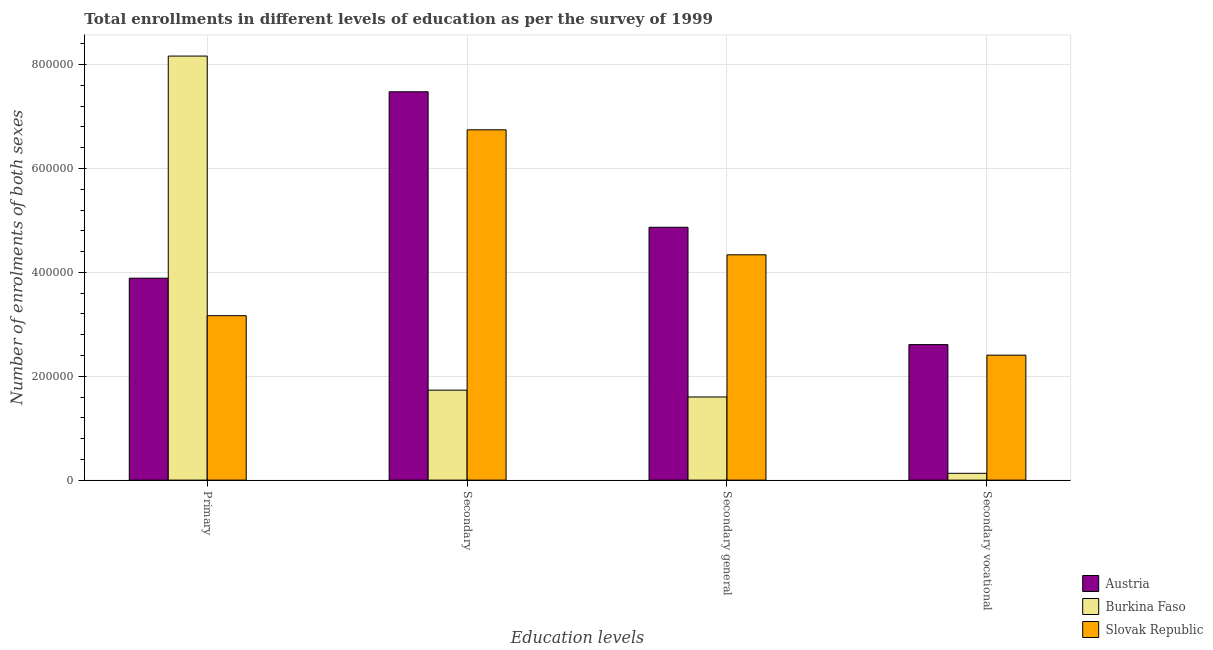How many different coloured bars are there?
Offer a very short reply. 3. How many groups of bars are there?
Ensure brevity in your answer.  4. Are the number of bars per tick equal to the number of legend labels?
Your answer should be very brief. Yes. How many bars are there on the 1st tick from the left?
Your answer should be compact. 3. What is the label of the 3rd group of bars from the left?
Offer a terse response. Secondary general. What is the number of enrolments in primary education in Slovak Republic?
Keep it short and to the point. 3.17e+05. Across all countries, what is the maximum number of enrolments in secondary education?
Your answer should be compact. 7.48e+05. Across all countries, what is the minimum number of enrolments in secondary vocational education?
Keep it short and to the point. 1.31e+04. In which country was the number of enrolments in secondary education maximum?
Your response must be concise. Austria. In which country was the number of enrolments in secondary education minimum?
Make the answer very short. Burkina Faso. What is the total number of enrolments in secondary education in the graph?
Offer a terse response. 1.60e+06. What is the difference between the number of enrolments in primary education in Burkina Faso and that in Austria?
Your answer should be very brief. 4.28e+05. What is the difference between the number of enrolments in primary education in Slovak Republic and the number of enrolments in secondary vocational education in Austria?
Ensure brevity in your answer.  5.57e+04. What is the average number of enrolments in secondary education per country?
Offer a terse response. 5.32e+05. What is the difference between the number of enrolments in secondary vocational education and number of enrolments in primary education in Burkina Faso?
Keep it short and to the point. -8.03e+05. In how many countries, is the number of enrolments in secondary education greater than 680000 ?
Provide a short and direct response. 1. What is the ratio of the number of enrolments in primary education in Burkina Faso to that in Austria?
Ensure brevity in your answer.  2.1. Is the difference between the number of enrolments in secondary vocational education in Austria and Slovak Republic greater than the difference between the number of enrolments in secondary education in Austria and Slovak Republic?
Offer a very short reply. No. What is the difference between the highest and the second highest number of enrolments in secondary general education?
Offer a very short reply. 5.30e+04. What is the difference between the highest and the lowest number of enrolments in secondary general education?
Make the answer very short. 3.27e+05. In how many countries, is the number of enrolments in secondary general education greater than the average number of enrolments in secondary general education taken over all countries?
Provide a succinct answer. 2. Is the sum of the number of enrolments in secondary general education in Austria and Slovak Republic greater than the maximum number of enrolments in secondary education across all countries?
Provide a short and direct response. Yes. Is it the case that in every country, the sum of the number of enrolments in secondary vocational education and number of enrolments in secondary general education is greater than the sum of number of enrolments in primary education and number of enrolments in secondary education?
Give a very brief answer. No. What does the 1st bar from the right in Secondary vocational represents?
Make the answer very short. Slovak Republic. Is it the case that in every country, the sum of the number of enrolments in primary education and number of enrolments in secondary education is greater than the number of enrolments in secondary general education?
Keep it short and to the point. Yes. How many bars are there?
Offer a very short reply. 12. How many countries are there in the graph?
Your answer should be very brief. 3. Does the graph contain grids?
Ensure brevity in your answer.  Yes. How are the legend labels stacked?
Keep it short and to the point. Vertical. What is the title of the graph?
Offer a terse response. Total enrollments in different levels of education as per the survey of 1999. Does "Cote d'Ivoire" appear as one of the legend labels in the graph?
Make the answer very short. No. What is the label or title of the X-axis?
Make the answer very short. Education levels. What is the label or title of the Y-axis?
Your answer should be very brief. Number of enrolments of both sexes. What is the Number of enrolments of both sexes in Austria in Primary?
Provide a succinct answer. 3.89e+05. What is the Number of enrolments of both sexes of Burkina Faso in Primary?
Offer a very short reply. 8.16e+05. What is the Number of enrolments of both sexes of Slovak Republic in Primary?
Provide a succinct answer. 3.17e+05. What is the Number of enrolments of both sexes of Austria in Secondary?
Keep it short and to the point. 7.48e+05. What is the Number of enrolments of both sexes of Burkina Faso in Secondary?
Your response must be concise. 1.73e+05. What is the Number of enrolments of both sexes of Slovak Republic in Secondary?
Keep it short and to the point. 6.74e+05. What is the Number of enrolments of both sexes of Austria in Secondary general?
Give a very brief answer. 4.87e+05. What is the Number of enrolments of both sexes in Burkina Faso in Secondary general?
Offer a very short reply. 1.60e+05. What is the Number of enrolments of both sexes of Slovak Republic in Secondary general?
Provide a short and direct response. 4.34e+05. What is the Number of enrolments of both sexes in Austria in Secondary vocational?
Your response must be concise. 2.61e+05. What is the Number of enrolments of both sexes in Burkina Faso in Secondary vocational?
Your answer should be very brief. 1.31e+04. What is the Number of enrolments of both sexes in Slovak Republic in Secondary vocational?
Offer a terse response. 2.41e+05. Across all Education levels, what is the maximum Number of enrolments of both sexes of Austria?
Ensure brevity in your answer.  7.48e+05. Across all Education levels, what is the maximum Number of enrolments of both sexes of Burkina Faso?
Ensure brevity in your answer.  8.16e+05. Across all Education levels, what is the maximum Number of enrolments of both sexes of Slovak Republic?
Make the answer very short. 6.74e+05. Across all Education levels, what is the minimum Number of enrolments of both sexes in Austria?
Your answer should be compact. 2.61e+05. Across all Education levels, what is the minimum Number of enrolments of both sexes of Burkina Faso?
Provide a short and direct response. 1.31e+04. Across all Education levels, what is the minimum Number of enrolments of both sexes of Slovak Republic?
Your answer should be compact. 2.41e+05. What is the total Number of enrolments of both sexes in Austria in the graph?
Make the answer very short. 1.88e+06. What is the total Number of enrolments of both sexes of Burkina Faso in the graph?
Your answer should be compact. 1.16e+06. What is the total Number of enrolments of both sexes in Slovak Republic in the graph?
Offer a very short reply. 1.67e+06. What is the difference between the Number of enrolments of both sexes in Austria in Primary and that in Secondary?
Provide a succinct answer. -3.59e+05. What is the difference between the Number of enrolments of both sexes of Burkina Faso in Primary and that in Secondary?
Offer a very short reply. 6.43e+05. What is the difference between the Number of enrolments of both sexes in Slovak Republic in Primary and that in Secondary?
Your answer should be very brief. -3.58e+05. What is the difference between the Number of enrolments of both sexes in Austria in Primary and that in Secondary general?
Make the answer very short. -9.80e+04. What is the difference between the Number of enrolments of both sexes in Burkina Faso in Primary and that in Secondary general?
Your answer should be very brief. 6.56e+05. What is the difference between the Number of enrolments of both sexes of Slovak Republic in Primary and that in Secondary general?
Provide a short and direct response. -1.17e+05. What is the difference between the Number of enrolments of both sexes of Austria in Primary and that in Secondary vocational?
Ensure brevity in your answer.  1.28e+05. What is the difference between the Number of enrolments of both sexes in Burkina Faso in Primary and that in Secondary vocational?
Your response must be concise. 8.03e+05. What is the difference between the Number of enrolments of both sexes in Slovak Republic in Primary and that in Secondary vocational?
Ensure brevity in your answer.  7.60e+04. What is the difference between the Number of enrolments of both sexes in Austria in Secondary and that in Secondary general?
Provide a short and direct response. 2.61e+05. What is the difference between the Number of enrolments of both sexes of Burkina Faso in Secondary and that in Secondary general?
Keep it short and to the point. 1.31e+04. What is the difference between the Number of enrolments of both sexes in Slovak Republic in Secondary and that in Secondary general?
Ensure brevity in your answer.  2.41e+05. What is the difference between the Number of enrolments of both sexes in Austria in Secondary and that in Secondary vocational?
Your response must be concise. 4.87e+05. What is the difference between the Number of enrolments of both sexes in Burkina Faso in Secondary and that in Secondary vocational?
Provide a short and direct response. 1.60e+05. What is the difference between the Number of enrolments of both sexes in Slovak Republic in Secondary and that in Secondary vocational?
Make the answer very short. 4.34e+05. What is the difference between the Number of enrolments of both sexes of Austria in Secondary general and that in Secondary vocational?
Your answer should be very brief. 2.26e+05. What is the difference between the Number of enrolments of both sexes of Burkina Faso in Secondary general and that in Secondary vocational?
Your response must be concise. 1.47e+05. What is the difference between the Number of enrolments of both sexes of Slovak Republic in Secondary general and that in Secondary vocational?
Provide a short and direct response. 1.93e+05. What is the difference between the Number of enrolments of both sexes of Austria in Primary and the Number of enrolments of both sexes of Burkina Faso in Secondary?
Keep it short and to the point. 2.16e+05. What is the difference between the Number of enrolments of both sexes in Austria in Primary and the Number of enrolments of both sexes in Slovak Republic in Secondary?
Give a very brief answer. -2.86e+05. What is the difference between the Number of enrolments of both sexes of Burkina Faso in Primary and the Number of enrolments of both sexes of Slovak Republic in Secondary?
Ensure brevity in your answer.  1.42e+05. What is the difference between the Number of enrolments of both sexes of Austria in Primary and the Number of enrolments of both sexes of Burkina Faso in Secondary general?
Your answer should be very brief. 2.29e+05. What is the difference between the Number of enrolments of both sexes of Austria in Primary and the Number of enrolments of both sexes of Slovak Republic in Secondary general?
Give a very brief answer. -4.50e+04. What is the difference between the Number of enrolments of both sexes in Burkina Faso in Primary and the Number of enrolments of both sexes in Slovak Republic in Secondary general?
Offer a very short reply. 3.83e+05. What is the difference between the Number of enrolments of both sexes in Austria in Primary and the Number of enrolments of both sexes in Burkina Faso in Secondary vocational?
Ensure brevity in your answer.  3.76e+05. What is the difference between the Number of enrolments of both sexes in Austria in Primary and the Number of enrolments of both sexes in Slovak Republic in Secondary vocational?
Your answer should be compact. 1.48e+05. What is the difference between the Number of enrolments of both sexes of Burkina Faso in Primary and the Number of enrolments of both sexes of Slovak Republic in Secondary vocational?
Your response must be concise. 5.76e+05. What is the difference between the Number of enrolments of both sexes in Austria in Secondary and the Number of enrolments of both sexes in Burkina Faso in Secondary general?
Ensure brevity in your answer.  5.88e+05. What is the difference between the Number of enrolments of both sexes in Austria in Secondary and the Number of enrolments of both sexes in Slovak Republic in Secondary general?
Keep it short and to the point. 3.14e+05. What is the difference between the Number of enrolments of both sexes in Burkina Faso in Secondary and the Number of enrolments of both sexes in Slovak Republic in Secondary general?
Provide a succinct answer. -2.61e+05. What is the difference between the Number of enrolments of both sexes in Austria in Secondary and the Number of enrolments of both sexes in Burkina Faso in Secondary vocational?
Your answer should be very brief. 7.35e+05. What is the difference between the Number of enrolments of both sexes of Austria in Secondary and the Number of enrolments of both sexes of Slovak Republic in Secondary vocational?
Your response must be concise. 5.07e+05. What is the difference between the Number of enrolments of both sexes of Burkina Faso in Secondary and the Number of enrolments of both sexes of Slovak Republic in Secondary vocational?
Provide a succinct answer. -6.74e+04. What is the difference between the Number of enrolments of both sexes of Austria in Secondary general and the Number of enrolments of both sexes of Burkina Faso in Secondary vocational?
Your response must be concise. 4.74e+05. What is the difference between the Number of enrolments of both sexes of Austria in Secondary general and the Number of enrolments of both sexes of Slovak Republic in Secondary vocational?
Make the answer very short. 2.46e+05. What is the difference between the Number of enrolments of both sexes in Burkina Faso in Secondary general and the Number of enrolments of both sexes in Slovak Republic in Secondary vocational?
Make the answer very short. -8.05e+04. What is the average Number of enrolments of both sexes of Austria per Education levels?
Give a very brief answer. 4.71e+05. What is the average Number of enrolments of both sexes of Burkina Faso per Education levels?
Provide a succinct answer. 2.91e+05. What is the average Number of enrolments of both sexes of Slovak Republic per Education levels?
Offer a terse response. 4.16e+05. What is the difference between the Number of enrolments of both sexes in Austria and Number of enrolments of both sexes in Burkina Faso in Primary?
Offer a terse response. -4.28e+05. What is the difference between the Number of enrolments of both sexes of Austria and Number of enrolments of both sexes of Slovak Republic in Primary?
Keep it short and to the point. 7.22e+04. What is the difference between the Number of enrolments of both sexes in Burkina Faso and Number of enrolments of both sexes in Slovak Republic in Primary?
Offer a very short reply. 5.00e+05. What is the difference between the Number of enrolments of both sexes of Austria and Number of enrolments of both sexes of Burkina Faso in Secondary?
Make the answer very short. 5.74e+05. What is the difference between the Number of enrolments of both sexes of Austria and Number of enrolments of both sexes of Slovak Republic in Secondary?
Offer a very short reply. 7.33e+04. What is the difference between the Number of enrolments of both sexes in Burkina Faso and Number of enrolments of both sexes in Slovak Republic in Secondary?
Keep it short and to the point. -5.01e+05. What is the difference between the Number of enrolments of both sexes in Austria and Number of enrolments of both sexes in Burkina Faso in Secondary general?
Provide a short and direct response. 3.27e+05. What is the difference between the Number of enrolments of both sexes in Austria and Number of enrolments of both sexes in Slovak Republic in Secondary general?
Offer a terse response. 5.30e+04. What is the difference between the Number of enrolments of both sexes of Burkina Faso and Number of enrolments of both sexes of Slovak Republic in Secondary general?
Offer a terse response. -2.74e+05. What is the difference between the Number of enrolments of both sexes in Austria and Number of enrolments of both sexes in Burkina Faso in Secondary vocational?
Offer a very short reply. 2.48e+05. What is the difference between the Number of enrolments of both sexes of Austria and Number of enrolments of both sexes of Slovak Republic in Secondary vocational?
Offer a very short reply. 2.03e+04. What is the difference between the Number of enrolments of both sexes of Burkina Faso and Number of enrolments of both sexes of Slovak Republic in Secondary vocational?
Give a very brief answer. -2.27e+05. What is the ratio of the Number of enrolments of both sexes of Austria in Primary to that in Secondary?
Give a very brief answer. 0.52. What is the ratio of the Number of enrolments of both sexes in Burkina Faso in Primary to that in Secondary?
Your answer should be very brief. 4.71. What is the ratio of the Number of enrolments of both sexes of Slovak Republic in Primary to that in Secondary?
Ensure brevity in your answer.  0.47. What is the ratio of the Number of enrolments of both sexes in Austria in Primary to that in Secondary general?
Provide a short and direct response. 0.8. What is the ratio of the Number of enrolments of both sexes of Burkina Faso in Primary to that in Secondary general?
Make the answer very short. 5.1. What is the ratio of the Number of enrolments of both sexes of Slovak Republic in Primary to that in Secondary general?
Provide a succinct answer. 0.73. What is the ratio of the Number of enrolments of both sexes of Austria in Primary to that in Secondary vocational?
Your answer should be very brief. 1.49. What is the ratio of the Number of enrolments of both sexes in Burkina Faso in Primary to that in Secondary vocational?
Provide a short and direct response. 62.28. What is the ratio of the Number of enrolments of both sexes of Slovak Republic in Primary to that in Secondary vocational?
Your answer should be compact. 1.32. What is the ratio of the Number of enrolments of both sexes of Austria in Secondary to that in Secondary general?
Offer a very short reply. 1.54. What is the ratio of the Number of enrolments of both sexes in Burkina Faso in Secondary to that in Secondary general?
Your answer should be compact. 1.08. What is the ratio of the Number of enrolments of both sexes of Slovak Republic in Secondary to that in Secondary general?
Provide a short and direct response. 1.55. What is the ratio of the Number of enrolments of both sexes in Austria in Secondary to that in Secondary vocational?
Give a very brief answer. 2.87. What is the ratio of the Number of enrolments of both sexes in Burkina Faso in Secondary to that in Secondary vocational?
Provide a succinct answer. 13.21. What is the ratio of the Number of enrolments of both sexes in Slovak Republic in Secondary to that in Secondary vocational?
Offer a terse response. 2.8. What is the ratio of the Number of enrolments of both sexes of Austria in Secondary general to that in Secondary vocational?
Your answer should be very brief. 1.87. What is the ratio of the Number of enrolments of both sexes in Burkina Faso in Secondary general to that in Secondary vocational?
Offer a terse response. 12.21. What is the ratio of the Number of enrolments of both sexes in Slovak Republic in Secondary general to that in Secondary vocational?
Your answer should be compact. 1.8. What is the difference between the highest and the second highest Number of enrolments of both sexes of Austria?
Your answer should be very brief. 2.61e+05. What is the difference between the highest and the second highest Number of enrolments of both sexes of Burkina Faso?
Offer a very short reply. 6.43e+05. What is the difference between the highest and the second highest Number of enrolments of both sexes in Slovak Republic?
Provide a succinct answer. 2.41e+05. What is the difference between the highest and the lowest Number of enrolments of both sexes of Austria?
Offer a very short reply. 4.87e+05. What is the difference between the highest and the lowest Number of enrolments of both sexes of Burkina Faso?
Your answer should be very brief. 8.03e+05. What is the difference between the highest and the lowest Number of enrolments of both sexes in Slovak Republic?
Your answer should be very brief. 4.34e+05. 